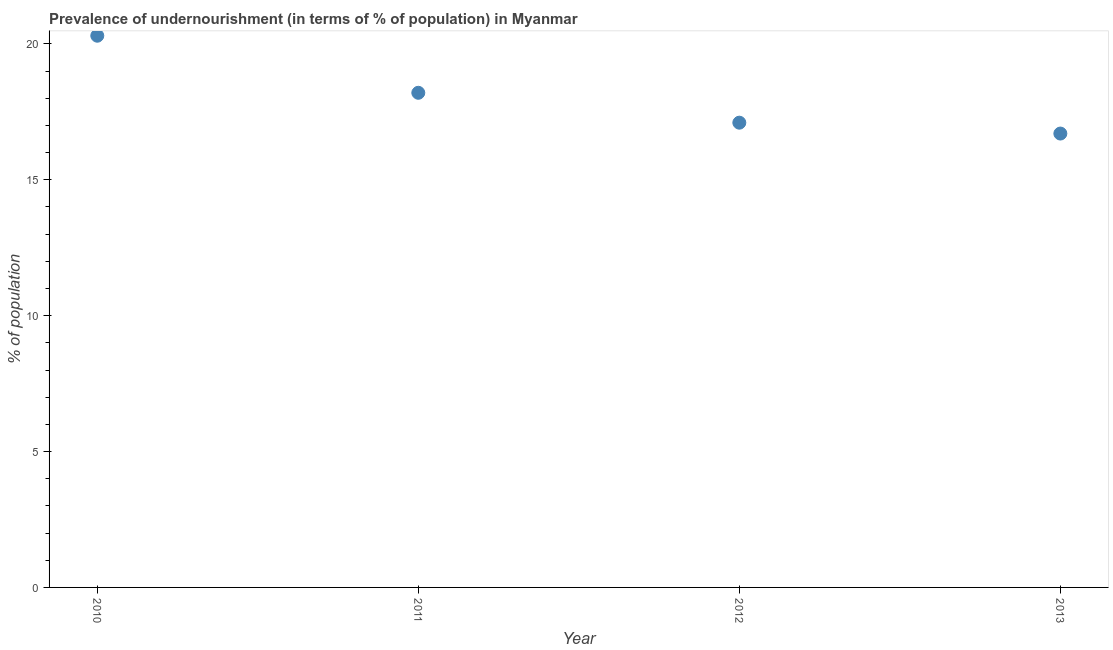What is the percentage of undernourished population in 2010?
Give a very brief answer. 20.3. Across all years, what is the maximum percentage of undernourished population?
Offer a terse response. 20.3. In which year was the percentage of undernourished population minimum?
Keep it short and to the point. 2013. What is the sum of the percentage of undernourished population?
Offer a terse response. 72.3. What is the difference between the percentage of undernourished population in 2010 and 2011?
Make the answer very short. 2.1. What is the average percentage of undernourished population per year?
Offer a very short reply. 18.07. What is the median percentage of undernourished population?
Make the answer very short. 17.65. Do a majority of the years between 2011 and 2010 (inclusive) have percentage of undernourished population greater than 1 %?
Provide a succinct answer. No. What is the ratio of the percentage of undernourished population in 2011 to that in 2013?
Make the answer very short. 1.09. What is the difference between the highest and the second highest percentage of undernourished population?
Give a very brief answer. 2.1. What is the difference between the highest and the lowest percentage of undernourished population?
Your answer should be compact. 3.6. In how many years, is the percentage of undernourished population greater than the average percentage of undernourished population taken over all years?
Keep it short and to the point. 2. How many dotlines are there?
Your answer should be very brief. 1. Are the values on the major ticks of Y-axis written in scientific E-notation?
Offer a terse response. No. Does the graph contain any zero values?
Your response must be concise. No. Does the graph contain grids?
Give a very brief answer. No. What is the title of the graph?
Your answer should be very brief. Prevalence of undernourishment (in terms of % of population) in Myanmar. What is the label or title of the X-axis?
Provide a succinct answer. Year. What is the label or title of the Y-axis?
Offer a very short reply. % of population. What is the % of population in 2010?
Keep it short and to the point. 20.3. What is the ratio of the % of population in 2010 to that in 2011?
Offer a terse response. 1.11. What is the ratio of the % of population in 2010 to that in 2012?
Provide a short and direct response. 1.19. What is the ratio of the % of population in 2010 to that in 2013?
Keep it short and to the point. 1.22. What is the ratio of the % of population in 2011 to that in 2012?
Ensure brevity in your answer.  1.06. What is the ratio of the % of population in 2011 to that in 2013?
Give a very brief answer. 1.09. What is the ratio of the % of population in 2012 to that in 2013?
Give a very brief answer. 1.02. 